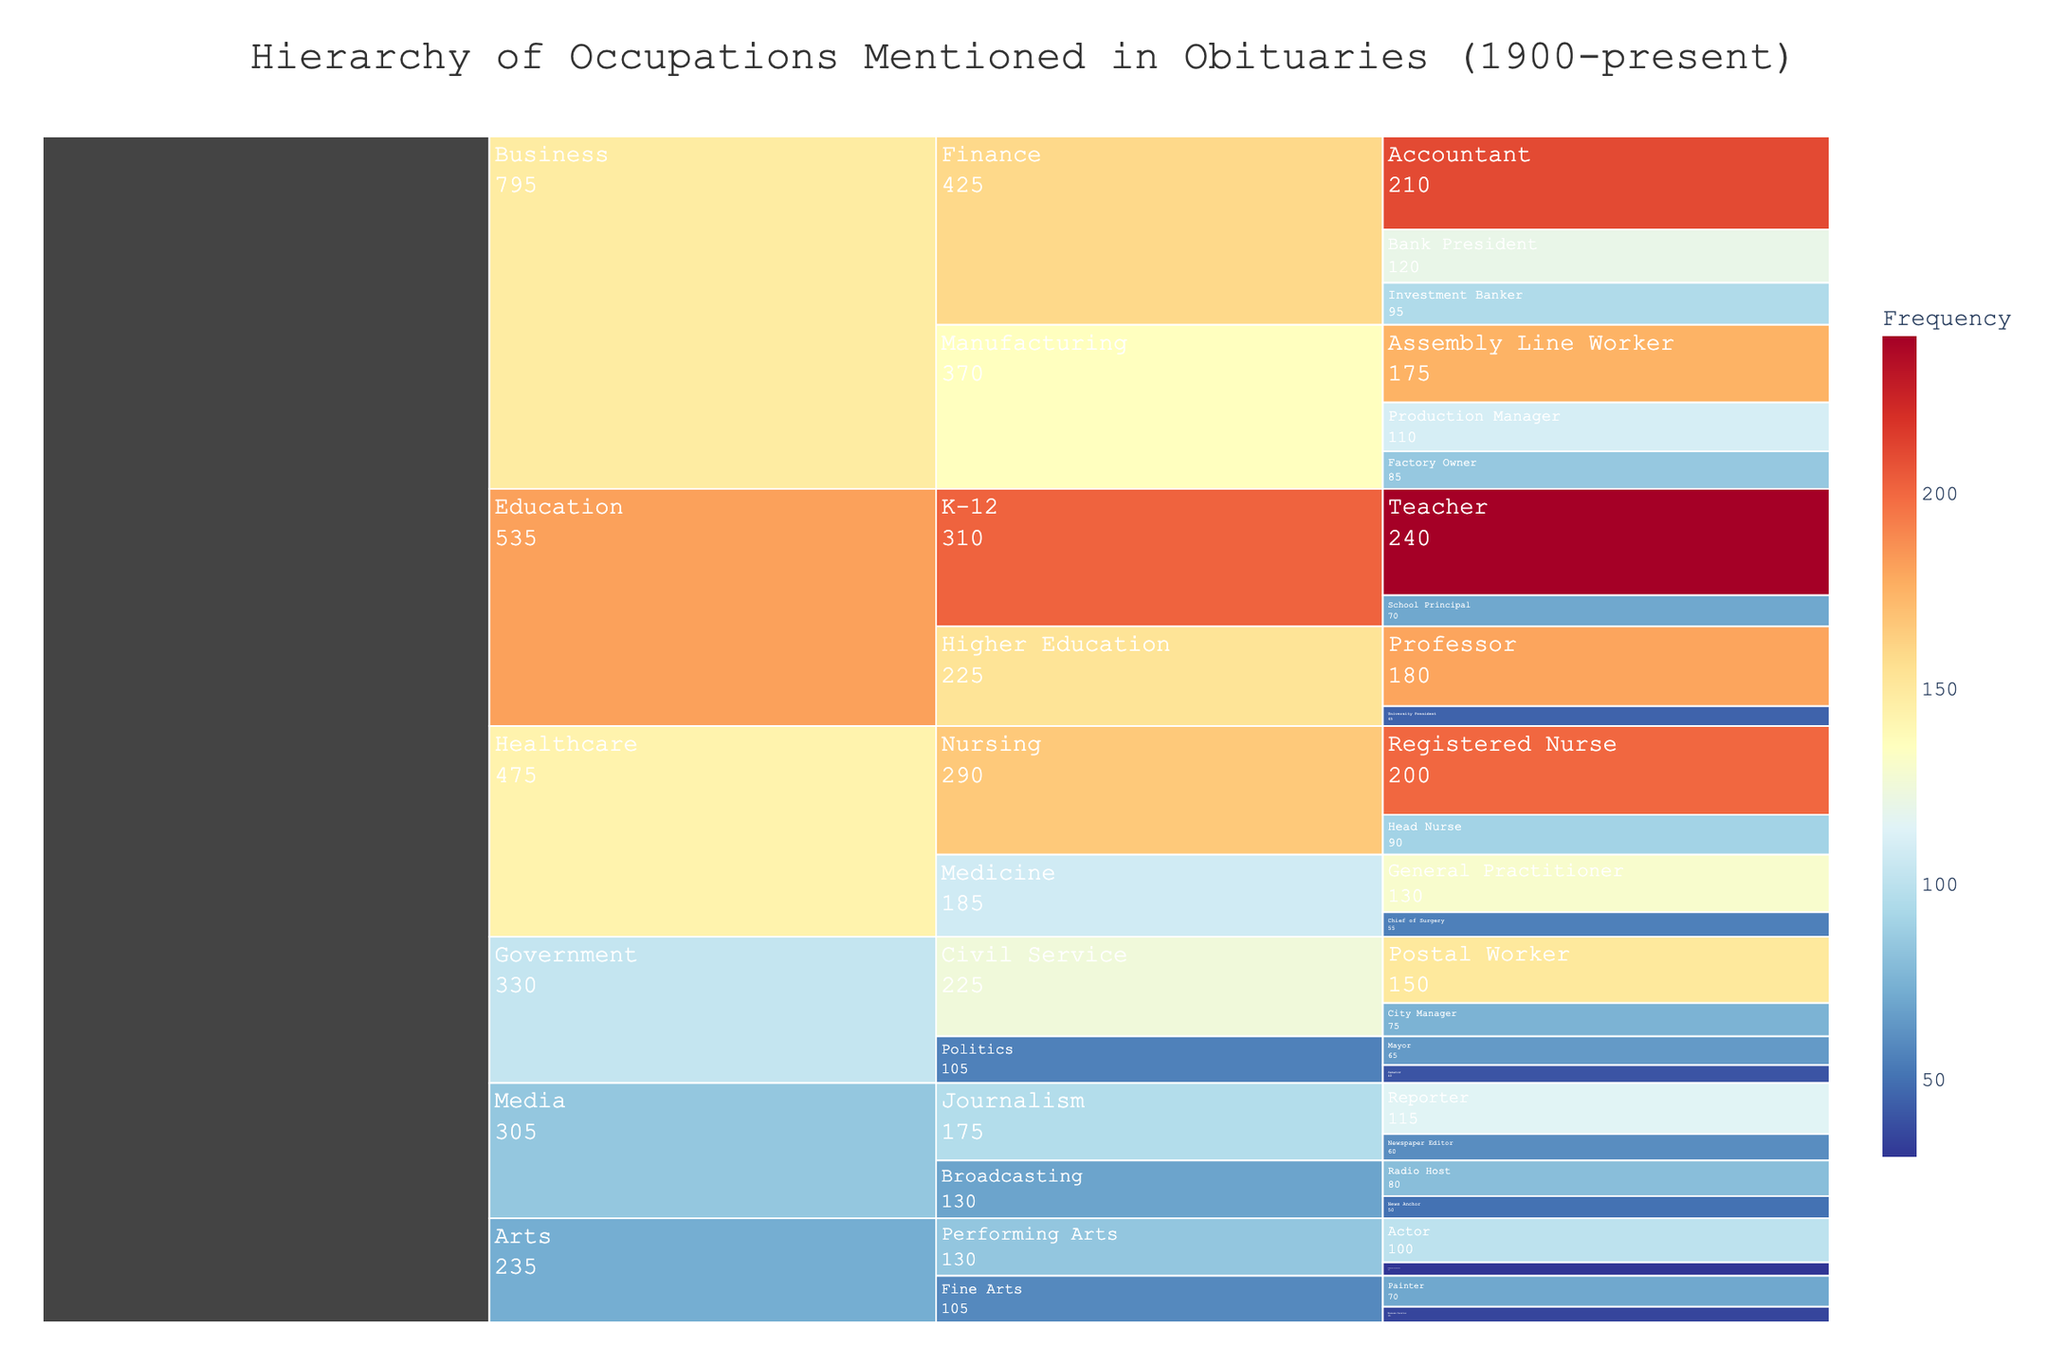What is the title of the icicle chart? The title of the icicle chart is provided clearly at the top of the figure. It reads "Hierarchy of Occupations Mentioned in Obituaries (1900-present)".
Answer: Hierarchy of Occupations Mentioned in Obituaries (1900-present) Which job type within the Education sector is mentioned most frequently in the obituaries? Referring to the chart under the Education sector, the job type "Teacher" has the highest frequency indicated by the largest section.
Answer: Teacher How many job types are listed under the Healthcare sector? The Healthcare sector consists of job types under Medicine and Nursing. Summing these, they are "Chief of Surgery", "General Practitioner", "Head Nurse", and "Registered Nurse", making a total of four.
Answer: 4 Which sector in the Business industry has a higher total frequency: Finance or Manufacturing? To determine this, you must sum the frequencies of job types under each sector within the Business industry. Finance has frequencies: 120 (Bank President) + 95 (Investment Banker) + 210 (Accountant) = 425. Manufacturing has frequencies: 85 (Factory Owner) + 110 (Production Manager) + 175 (Assembly Line Worker) = 370. Finance thus has a higher total frequency.
Answer: Finance What is the combined frequency for job types "Journalist" and "News Anchor" in the Media sector? "Journalist" is not listed as a specific job type; it comprises "Newspaper Editor" and "Reporter". The frequencies for these job types are: Newspaper Editor (60) + Reporter (115) + News Anchor (50). Summing these gives 60 + 115 + 50 = 225.
Answer: 225 Are there more mentions of job types in the Government industry or the Media industry? By summing the frequencies of all job types under each industry: Government has frequencies: 65 (Mayor) + 40 (Senator) + 75 (City Manager) + 150 (Postal Worker) = 330. Media has frequencies: 60 (Newspaper Editor) + 115 (Reporter) + 50 (News Anchor) + 80 (Radio Host) = 305. Therefore, Government has more mentions.
Answer: Government Which job type in the Manufacturing sector of the Business industry has the least frequency? Looking at the chart under Business > Manufacturing, the job types listed are "Factory Owner" (85), "Production Manager" (110), and "Assembly Line Worker" (175). "Factory Owner" has the lowest frequency.
Answer: Factory Owner How does the frequency of "University President" compare to that of "School Principal" in the Education sector? "University President" has a frequency of 45, whereas "School Principal" has a frequency of 70. "School Principal" has a greater frequency than "University President".
Answer: School Principal What is the frequency difference between "General Practitioner" and "Registered Nurse" in the Healthcare sector? "General Practitioner" has a frequency of 130 while "Registered Nurse" has a frequency of 200. The difference is calculated as 200 - 130 = 70.
Answer: 70 Which industry has the job type with the highest frequency and what is the job type? Scanning through frequencies shown in all sectors, the highest frequency job type is "Teacher" in the Education sector with a frequency of 240.
Answer: Education, Teacher 